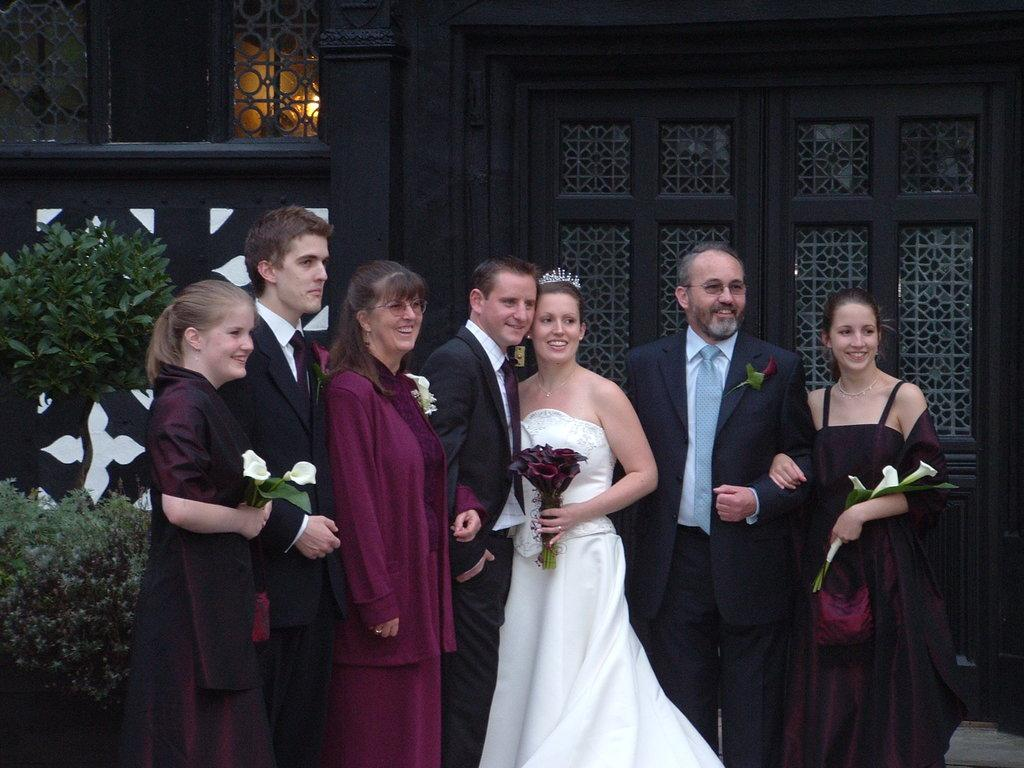What are the people in the image doing? The people in the image are standing. What are some of the people holding in their hands? Some people are holding flowers in their hands. What can be seen in the background of the image? There is a building in the background of the image. What type of vegetation is present in front of the building? Trees are present in front of the building in the image. What type of toys can be seen on the ground in the image? There are no toys visible on the ground in the image. 